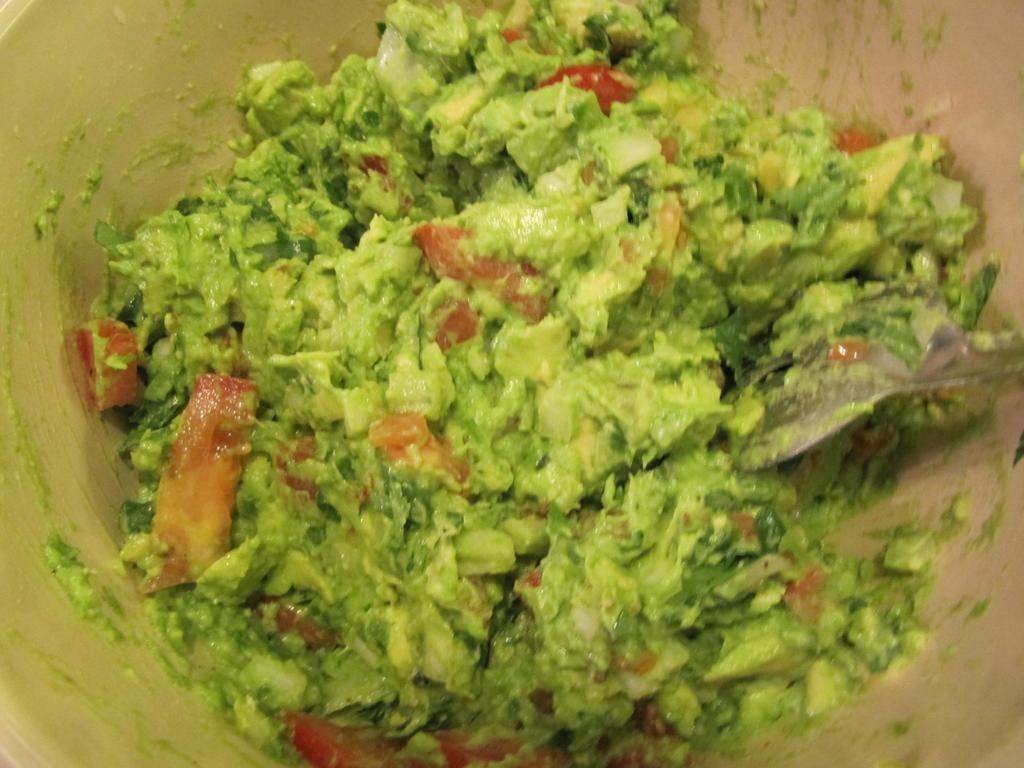What is being done to the food item in the image? The food item is being prepared in the image. What utensil can be seen in the image? A spoon is present in the image. Where is the food item located? The food item is in a bowl. What type of knife is being used to cut the breakfast in the image? There is no knife or breakfast present in the image; it only shows a food item being prepared in a bowl with a spoon. 